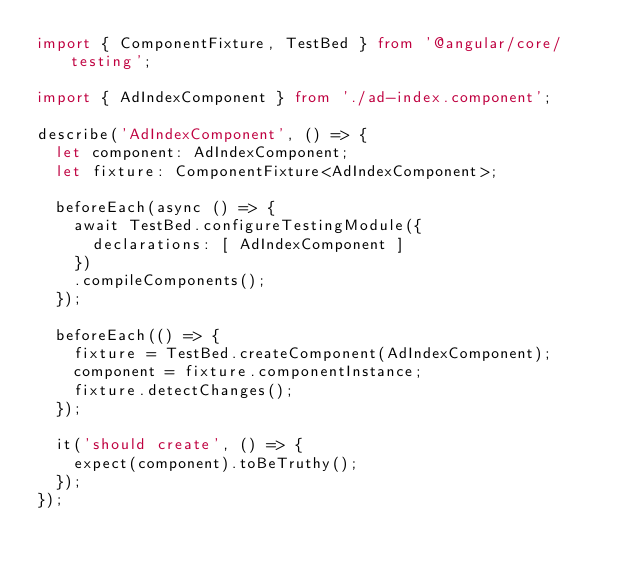Convert code to text. <code><loc_0><loc_0><loc_500><loc_500><_TypeScript_>import { ComponentFixture, TestBed } from '@angular/core/testing';

import { AdIndexComponent } from './ad-index.component';

describe('AdIndexComponent', () => {
  let component: AdIndexComponent;
  let fixture: ComponentFixture<AdIndexComponent>;

  beforeEach(async () => {
    await TestBed.configureTestingModule({
      declarations: [ AdIndexComponent ]
    })
    .compileComponents();
  });

  beforeEach(() => {
    fixture = TestBed.createComponent(AdIndexComponent);
    component = fixture.componentInstance;
    fixture.detectChanges();
  });

  it('should create', () => {
    expect(component).toBeTruthy();
  });
});
</code> 